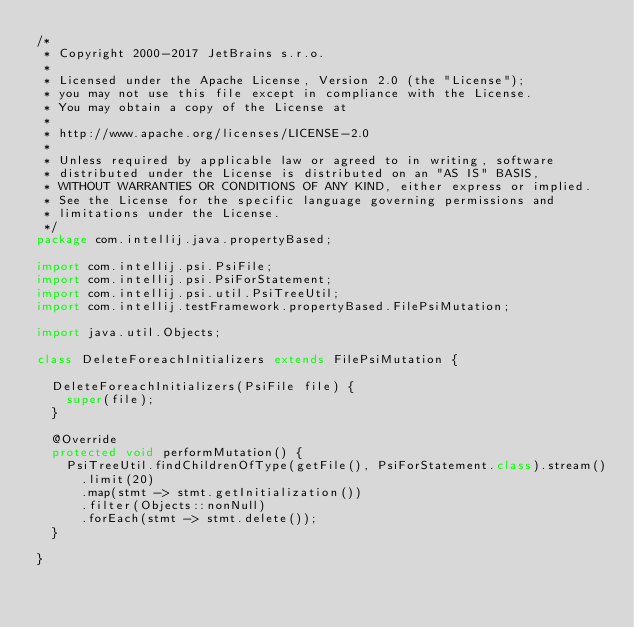<code> <loc_0><loc_0><loc_500><loc_500><_Java_>/*
 * Copyright 2000-2017 JetBrains s.r.o.
 *
 * Licensed under the Apache License, Version 2.0 (the "License");
 * you may not use this file except in compliance with the License.
 * You may obtain a copy of the License at
 *
 * http://www.apache.org/licenses/LICENSE-2.0
 *
 * Unless required by applicable law or agreed to in writing, software
 * distributed under the License is distributed on an "AS IS" BASIS,
 * WITHOUT WARRANTIES OR CONDITIONS OF ANY KIND, either express or implied.
 * See the License for the specific language governing permissions and
 * limitations under the License.
 */
package com.intellij.java.propertyBased;

import com.intellij.psi.PsiFile;
import com.intellij.psi.PsiForStatement;
import com.intellij.psi.util.PsiTreeUtil;
import com.intellij.testFramework.propertyBased.FilePsiMutation;

import java.util.Objects;

class DeleteForeachInitializers extends FilePsiMutation {

  DeleteForeachInitializers(PsiFile file) {
    super(file);
  }

  @Override
  protected void performMutation() {
    PsiTreeUtil.findChildrenOfType(getFile(), PsiForStatement.class).stream()
      .limit(20)
      .map(stmt -> stmt.getInitialization())
      .filter(Objects::nonNull)
      .forEach(stmt -> stmt.delete());
  }

}
</code> 